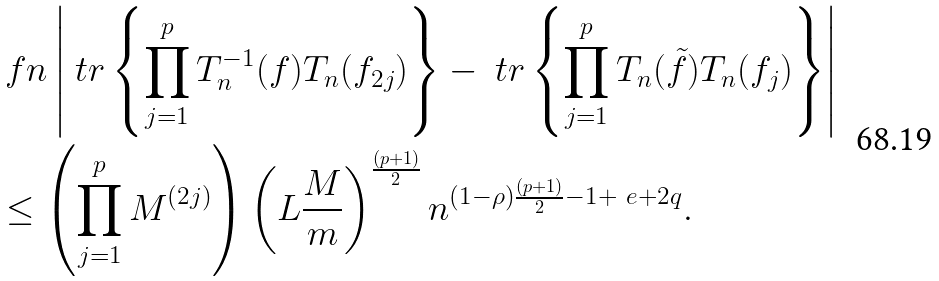Convert formula to latex. <formula><loc_0><loc_0><loc_500><loc_500>& \ f n \left | \ t r \left \{ \prod _ { j = 1 } ^ { p } T _ { n } ^ { - 1 } ( f ) T _ { n } ( f _ { 2 j } ) \right \} - \ t r \left \{ \prod _ { j = 1 } ^ { p } T _ { n } ( \tilde { f } ) T _ { n } ( f _ { j } ) \right \} \right | \\ & \leq \left ( \prod _ { j = 1 } ^ { p } M ^ { ( 2 j ) } \right ) \left ( L \frac { M } { m } \right ) ^ { \frac { ( p + 1 ) } { 2 } } n ^ { ( 1 - \rho ) \frac { ( p + 1 ) } { 2 } - 1 + \ e + 2 q } .</formula> 